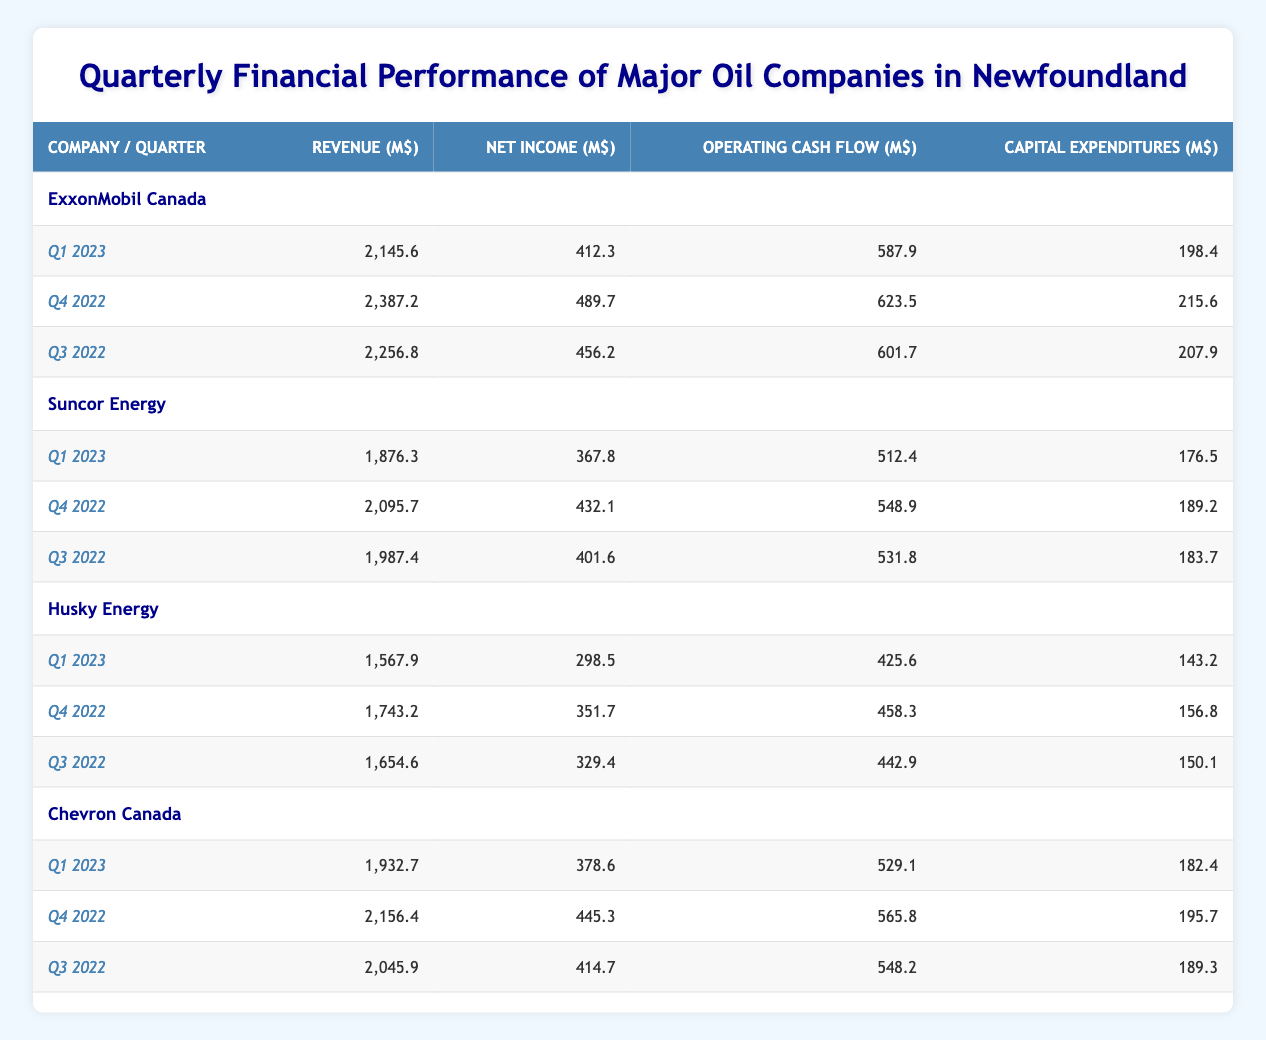What was the net income of Suncor Energy in Q4 2022? The net income for Suncor Energy in Q4 2022 is explicitly listed in the table under the respective quarter. Referring to the table, I find that Suncor Energy has a net income of 432.1 million dollars for that quarter.
Answer: 432.1 million dollars Which company had the highest revenue in Q1 2023? To determine which company had the highest revenue in Q1 2023, I can compare the revenue figures for that quarter across all companies. ExxonMobil Canada has 2145.6 million dollars, Suncor Energy has 1876.3 million dollars, Husky Energy has 1567.9 million dollars, and Chevron Canada has 1932.7 million dollars. The highest value among these is from ExxonMobil Canada.
Answer: ExxonMobil Canada What is the total capital expenditures for Husky Energy across all available quarters? I will sum up the capital expenditures of Husky Energy from the table. For Q1 2023, it's 143.2 million dollars, for Q4 2022 it's 156.8 million dollars, and for Q3 2022 it's 150.1 million dollars. Adding these amounts gives me: 143.2 + 156.8 + 150.1 = 450.1 million dollars.
Answer: 450.1 million dollars Did Chevron Canada have a higher operating cash flow in Q3 2022 than ExxonMobil Canada? To answer this, I will look at the operating cash flow figures for both companies in Q3 2022. Chevron Canada has 548.2 million dollars, while ExxonMobil Canada has 601.7 million dollars. Since 548.2 is less than 601.7, Chevron Canada did not have a higher operating cash flow.
Answer: No What was the average net income for all companies in Q1 2023? First, I need to find the net income for each company in Q1 2023: ExxonMobil Canada has 412.3 million dollars, Suncor Energy has 367.8 million dollars, Husky Energy has 298.5 million dollars, and Chevron Canada has 378.6 million dollars. Adding these values gives me: 412.3 + 367.8 + 298.5 + 378.6 = 1457.2 million dollars. To find the average, I divide this by the number of companies, which is 4: 1457.2 / 4 = 364.3 million dollars.
Answer: 364.3 million dollars Which company’s revenue declined from Q4 2022 to Q1 2023? I will compare the revenues from Q4 2022 to Q1 2023 for all companies. ExxonMobil Canada went from 2387.2 to 2145.6 (decline), Suncor Energy went from 2095.7 to 1876.3 (decline), Husky Energy went from 1743.2 to 1567.9 (decline), and Chevron Canada went from 2156.4 to 1932.7 (decline). All companies experienced a decline.
Answer: All companies What was the difference in operating cash flow between Suncor Energy and Husky Energy in Q1 2023? I'll look at the operating cash flow values for Suncor Energy and Husky Energy in Q1 2023. Suncor Energy's operating cash flow is 512.4 million dollars, and Husky Energy's is 425.6 million dollars. The difference is calculated as follows: 512.4 - 425.6 = 86.8 million dollars.
Answer: 86.8 million dollars 